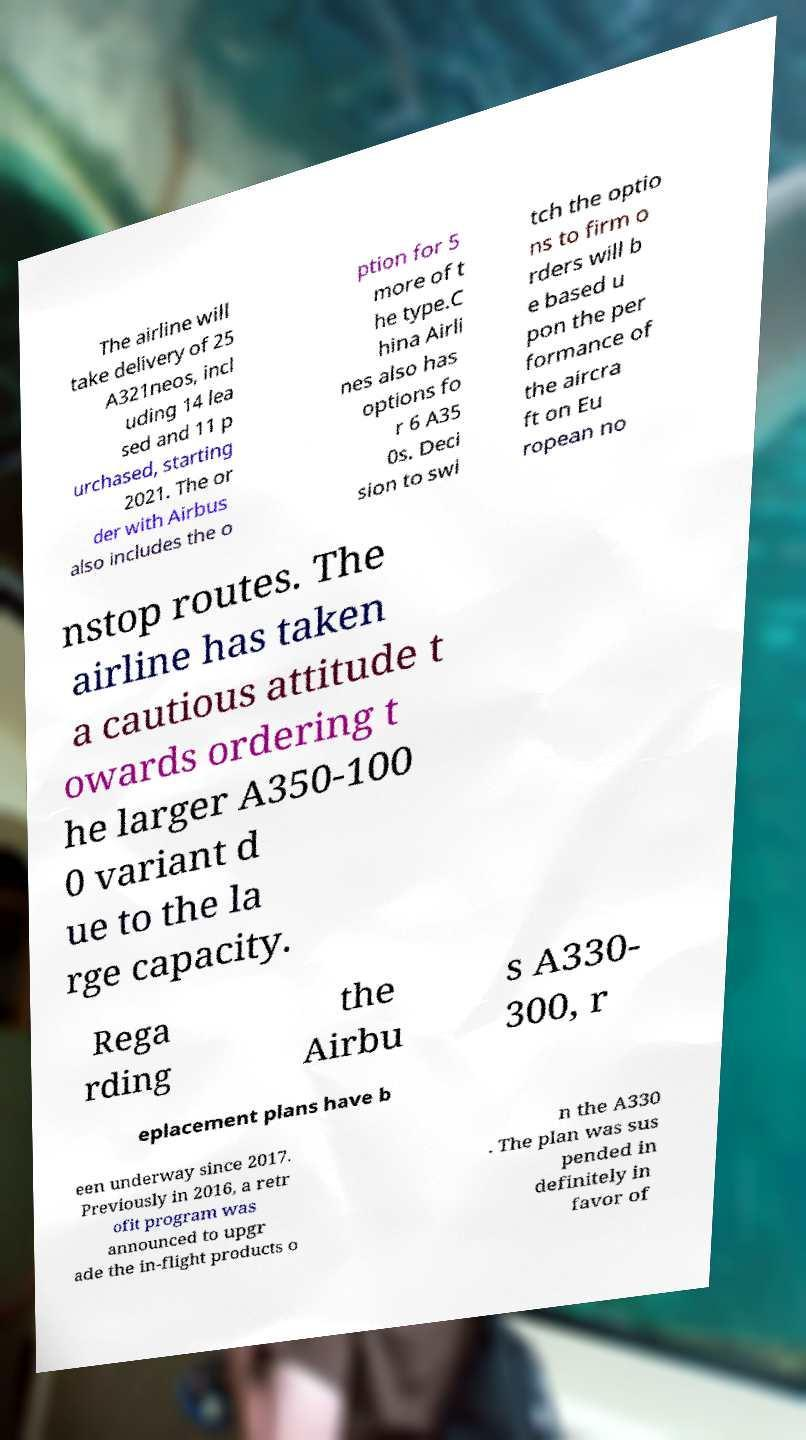Could you extract and type out the text from this image? The airline will take delivery of 25 A321neos, incl uding 14 lea sed and 11 p urchased, starting 2021. The or der with Airbus also includes the o ption for 5 more of t he type.C hina Airli nes also has options fo r 6 A35 0s. Deci sion to swi tch the optio ns to firm o rders will b e based u pon the per formance of the aircra ft on Eu ropean no nstop routes. The airline has taken a cautious attitude t owards ordering t he larger A350-100 0 variant d ue to the la rge capacity. Rega rding the Airbu s A330- 300, r eplacement plans have b een underway since 2017. Previously in 2016, a retr ofit program was announced to upgr ade the in-flight products o n the A330 . The plan was sus pended in definitely in favor of 